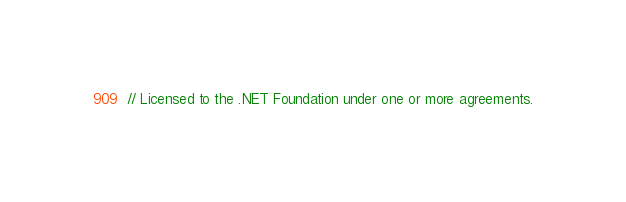<code> <loc_0><loc_0><loc_500><loc_500><_C++_>// Licensed to the .NET Foundation under one or more agreements.</code> 